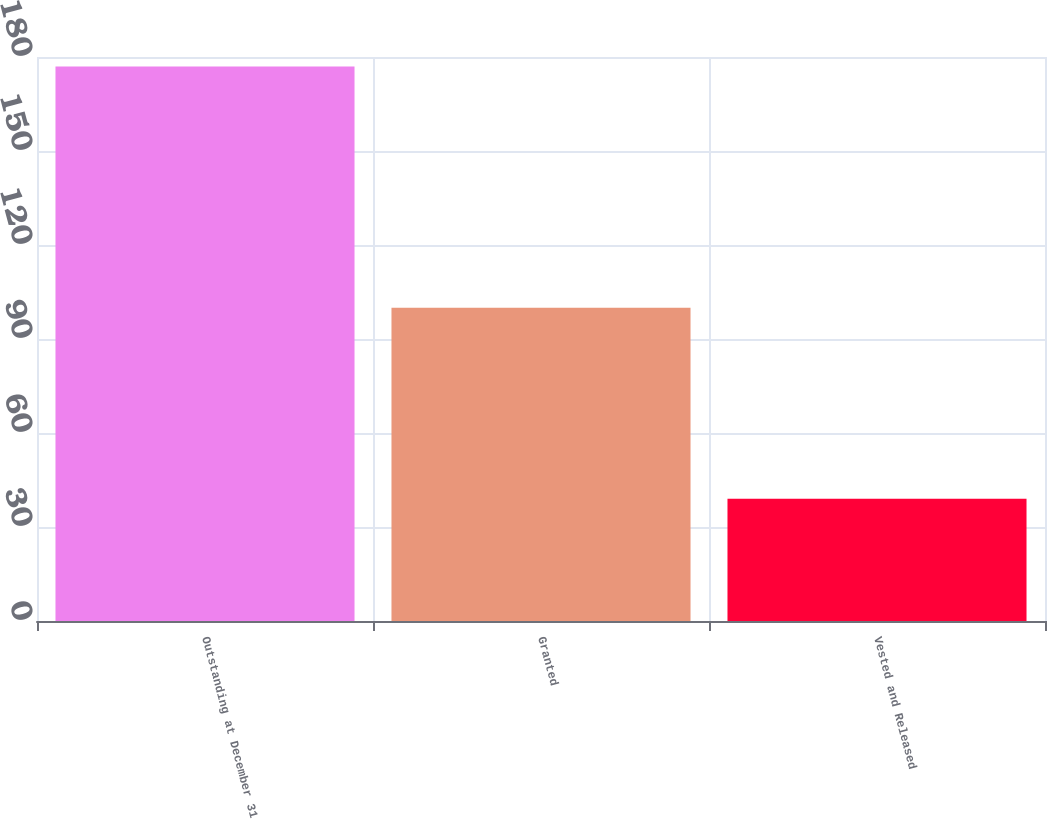<chart> <loc_0><loc_0><loc_500><loc_500><bar_chart><fcel>Outstanding at December 31<fcel>Granted<fcel>Vested and Released<nl><fcel>177<fcel>100<fcel>39<nl></chart> 